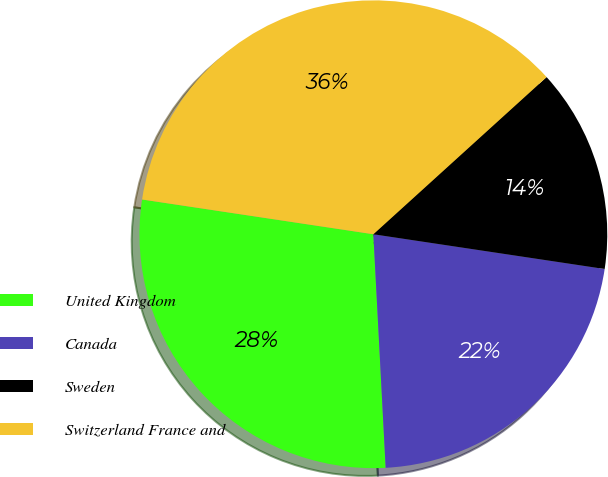Convert chart to OTSL. <chart><loc_0><loc_0><loc_500><loc_500><pie_chart><fcel>United Kingdom<fcel>Canada<fcel>Sweden<fcel>Switzerland France and<nl><fcel>28.21%<fcel>21.79%<fcel>14.1%<fcel>35.9%<nl></chart> 